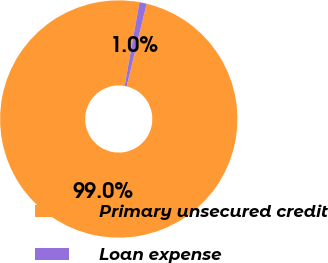Convert chart to OTSL. <chart><loc_0><loc_0><loc_500><loc_500><pie_chart><fcel>Primary unsecured credit<fcel>Loan expense<nl><fcel>99.02%<fcel>0.98%<nl></chart> 